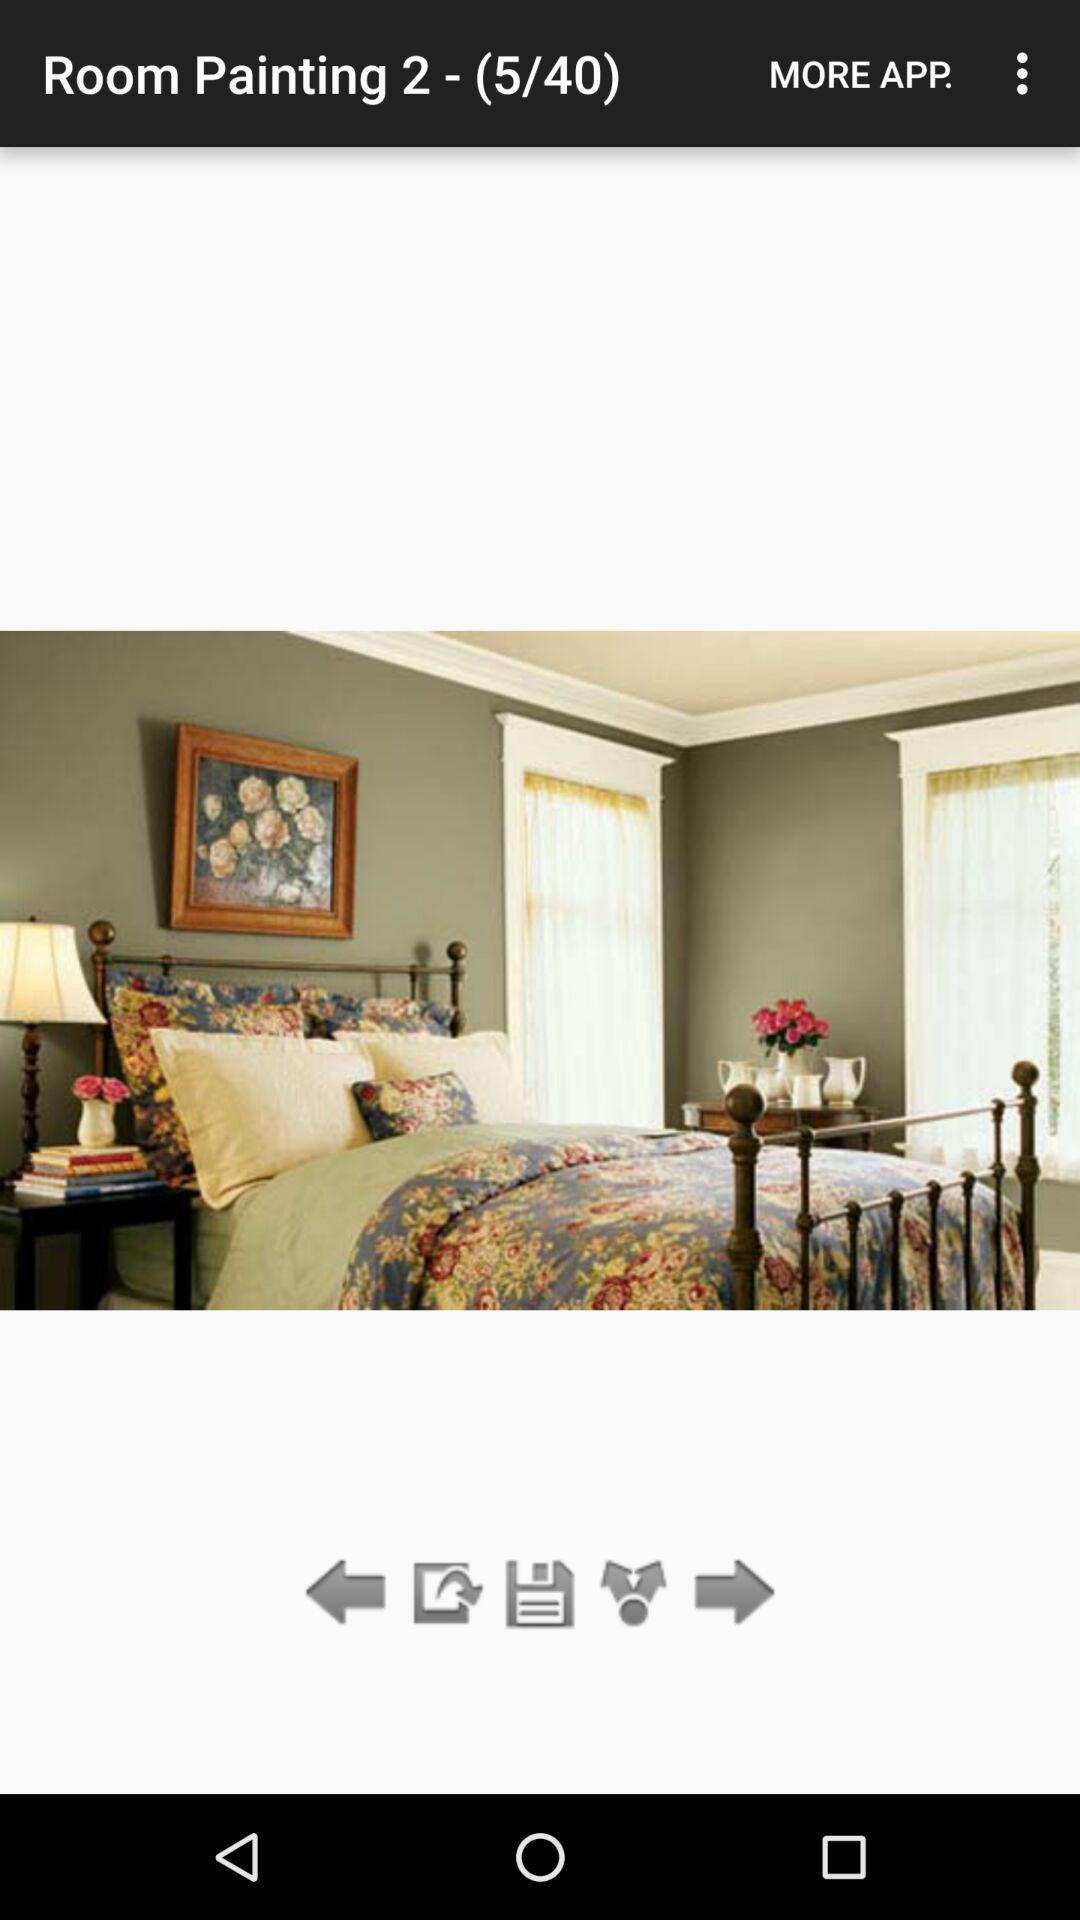On which slide number are we? You are on slide number 5. 